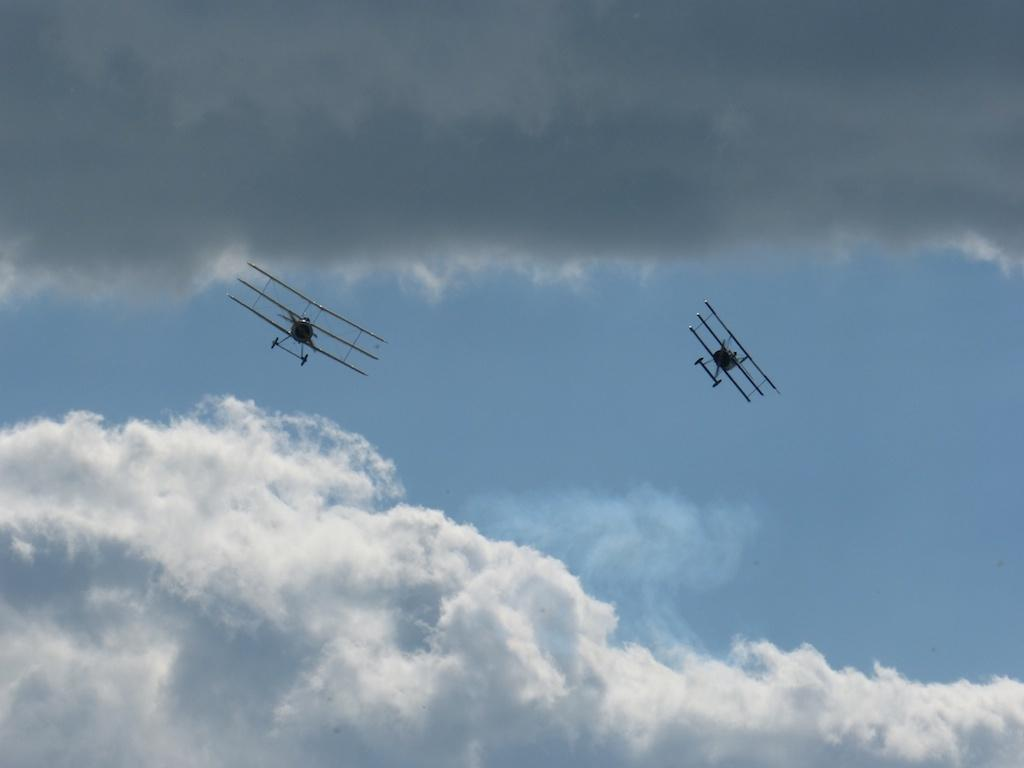How many airplanes are visible in the image? There are two airplanes in the image. What are the airplanes doing in the image? The airplanes are flying in the sky. What can be seen in the background of the image? There are clouds in the background of the image. What is the color of the sky in the image? The sky is blue in color. What type of celery is being used as a prop on the stage in the image? There is no celery or stage present in the image; it features two airplanes flying in the sky with a blue background and clouds. 